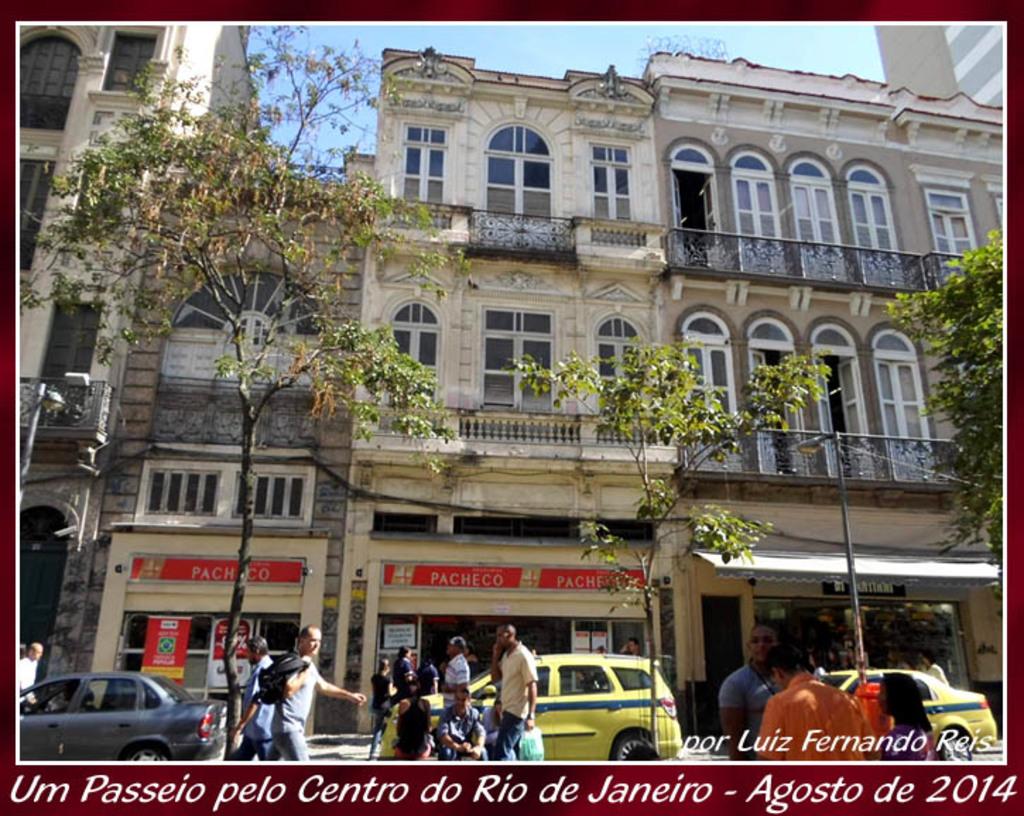This a kid?
Your answer should be compact. No. 